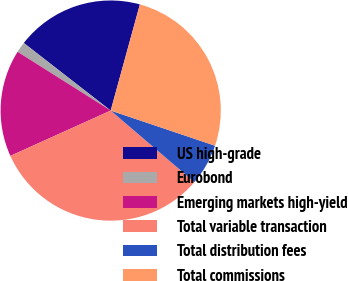Convert chart to OTSL. <chart><loc_0><loc_0><loc_500><loc_500><pie_chart><fcel>US high-grade<fcel>Eurobond<fcel>Emerging markets high-yield<fcel>Total variable transaction<fcel>Total distribution fees<fcel>Total commissions<nl><fcel>18.75%<fcel>1.56%<fcel>15.71%<fcel>31.99%<fcel>6.09%<fcel>25.9%<nl></chart> 